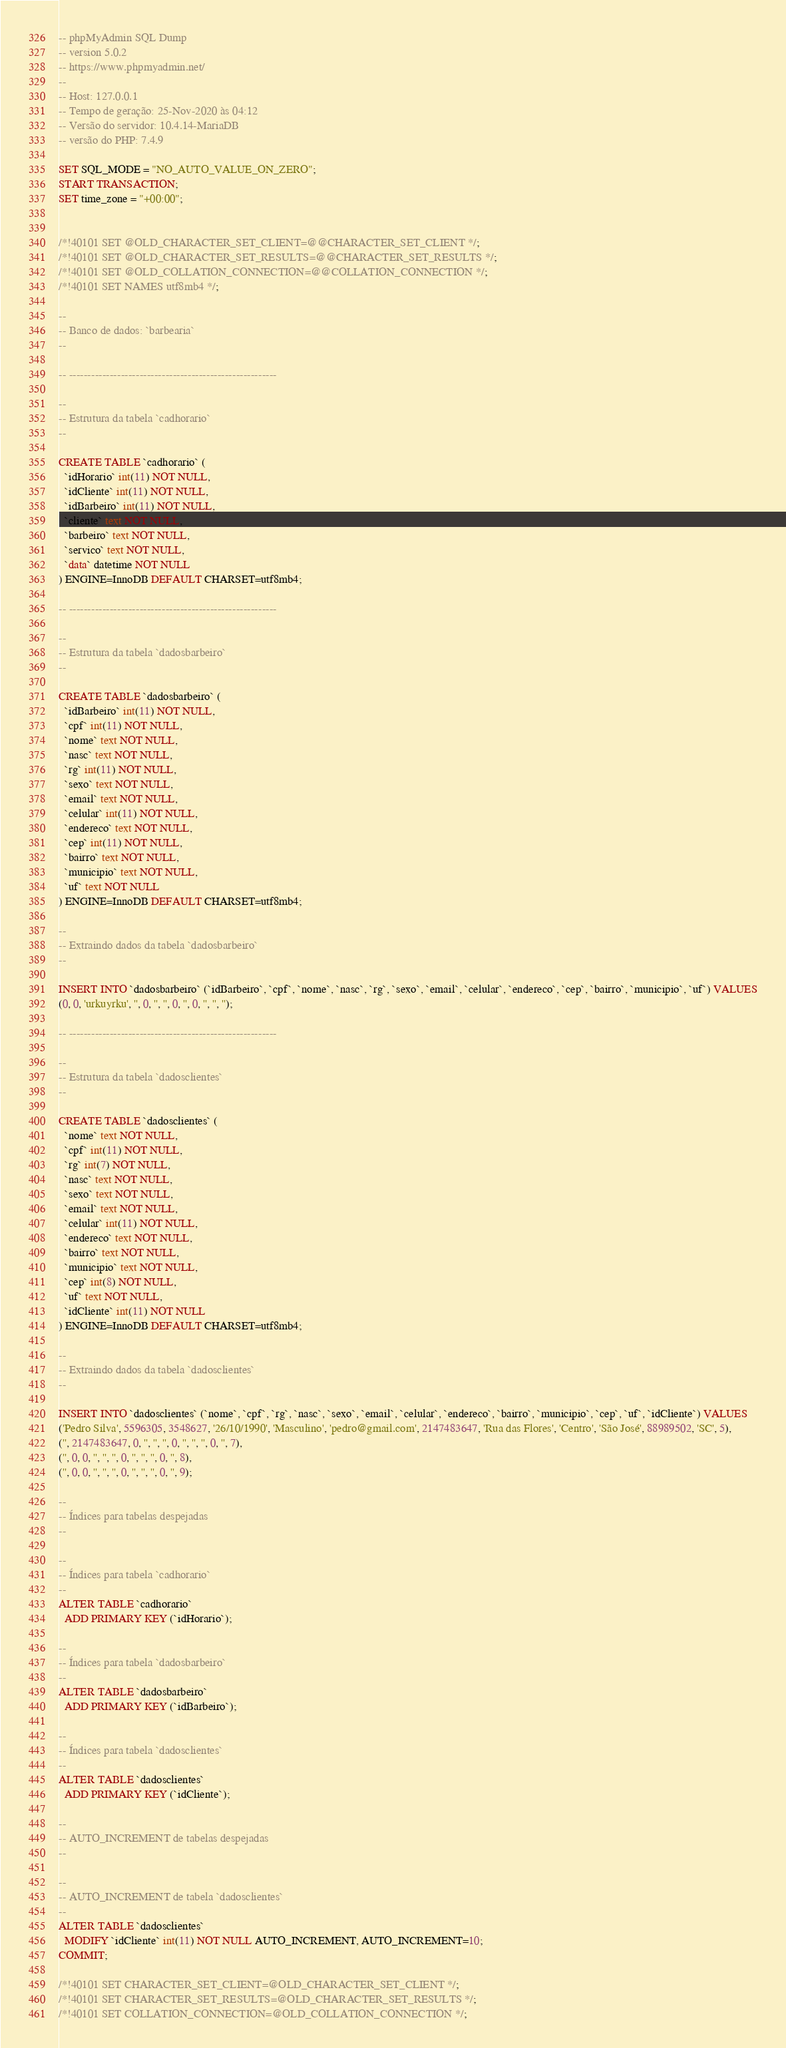<code> <loc_0><loc_0><loc_500><loc_500><_SQL_>-- phpMyAdmin SQL Dump
-- version 5.0.2
-- https://www.phpmyadmin.net/
--
-- Host: 127.0.0.1
-- Tempo de geração: 25-Nov-2020 às 04:12
-- Versão do servidor: 10.4.14-MariaDB
-- versão do PHP: 7.4.9

SET SQL_MODE = "NO_AUTO_VALUE_ON_ZERO";
START TRANSACTION;
SET time_zone = "+00:00";


/*!40101 SET @OLD_CHARACTER_SET_CLIENT=@@CHARACTER_SET_CLIENT */;
/*!40101 SET @OLD_CHARACTER_SET_RESULTS=@@CHARACTER_SET_RESULTS */;
/*!40101 SET @OLD_COLLATION_CONNECTION=@@COLLATION_CONNECTION */;
/*!40101 SET NAMES utf8mb4 */;

--
-- Banco de dados: `barbearia`
--

-- --------------------------------------------------------

--
-- Estrutura da tabela `cadhorario`
--

CREATE TABLE `cadhorario` (
  `idHorario` int(11) NOT NULL,
  `idCliente` int(11) NOT NULL,
  `idBarbeiro` int(11) NOT NULL,
  `cliente` text NOT NULL,
  `barbeiro` text NOT NULL,
  `servico` text NOT NULL,
  `data` datetime NOT NULL
) ENGINE=InnoDB DEFAULT CHARSET=utf8mb4;

-- --------------------------------------------------------

--
-- Estrutura da tabela `dadosbarbeiro`
--

CREATE TABLE `dadosbarbeiro` (
  `idBarbeiro` int(11) NOT NULL,
  `cpf` int(11) NOT NULL,
  `nome` text NOT NULL,
  `nasc` text NOT NULL,
  `rg` int(11) NOT NULL,
  `sexo` text NOT NULL,
  `email` text NOT NULL,
  `celular` int(11) NOT NULL,
  `endereco` text NOT NULL,
  `cep` int(11) NOT NULL,
  `bairro` text NOT NULL,
  `municipio` text NOT NULL,
  `uf` text NOT NULL
) ENGINE=InnoDB DEFAULT CHARSET=utf8mb4;

--
-- Extraindo dados da tabela `dadosbarbeiro`
--

INSERT INTO `dadosbarbeiro` (`idBarbeiro`, `cpf`, `nome`, `nasc`, `rg`, `sexo`, `email`, `celular`, `endereco`, `cep`, `bairro`, `municipio`, `uf`) VALUES
(0, 0, 'urkuyrku', '', 0, '', '', 0, '', 0, '', '', '');

-- --------------------------------------------------------

--
-- Estrutura da tabela `dadosclientes`
--

CREATE TABLE `dadosclientes` (
  `nome` text NOT NULL,
  `cpf` int(11) NOT NULL,
  `rg` int(7) NOT NULL,
  `nasc` text NOT NULL,
  `sexo` text NOT NULL,
  `email` text NOT NULL,
  `celular` int(11) NOT NULL,
  `endereco` text NOT NULL,
  `bairro` text NOT NULL,
  `municipio` text NOT NULL,
  `cep` int(8) NOT NULL,
  `uf` text NOT NULL,
  `idCliente` int(11) NOT NULL
) ENGINE=InnoDB DEFAULT CHARSET=utf8mb4;

--
-- Extraindo dados da tabela `dadosclientes`
--

INSERT INTO `dadosclientes` (`nome`, `cpf`, `rg`, `nasc`, `sexo`, `email`, `celular`, `endereco`, `bairro`, `municipio`, `cep`, `uf`, `idCliente`) VALUES
('Pedro Silva', 5596305, 3548627, '26/10/1990', 'Masculino', 'pedro@gmail.com', 2147483647, 'Rua das Flores', 'Centro', 'São José', 88989502, 'SC', 5),
('', 2147483647, 0, '', '', '', 0, '', '', '', 0, '', 7),
('', 0, 0, '', '', '', 0, '', '', '', 0, '', 8),
('', 0, 0, '', '', '', 0, '', '', '', 0, '', 9);

--
-- Índices para tabelas despejadas
--

--
-- Índices para tabela `cadhorario`
--
ALTER TABLE `cadhorario`
  ADD PRIMARY KEY (`idHorario`);

--
-- Índices para tabela `dadosbarbeiro`
--
ALTER TABLE `dadosbarbeiro`
  ADD PRIMARY KEY (`idBarbeiro`);

--
-- Índices para tabela `dadosclientes`
--
ALTER TABLE `dadosclientes`
  ADD PRIMARY KEY (`idCliente`);

--
-- AUTO_INCREMENT de tabelas despejadas
--

--
-- AUTO_INCREMENT de tabela `dadosclientes`
--
ALTER TABLE `dadosclientes`
  MODIFY `idCliente` int(11) NOT NULL AUTO_INCREMENT, AUTO_INCREMENT=10;
COMMIT;

/*!40101 SET CHARACTER_SET_CLIENT=@OLD_CHARACTER_SET_CLIENT */;
/*!40101 SET CHARACTER_SET_RESULTS=@OLD_CHARACTER_SET_RESULTS */;
/*!40101 SET COLLATION_CONNECTION=@OLD_COLLATION_CONNECTION */;
</code> 